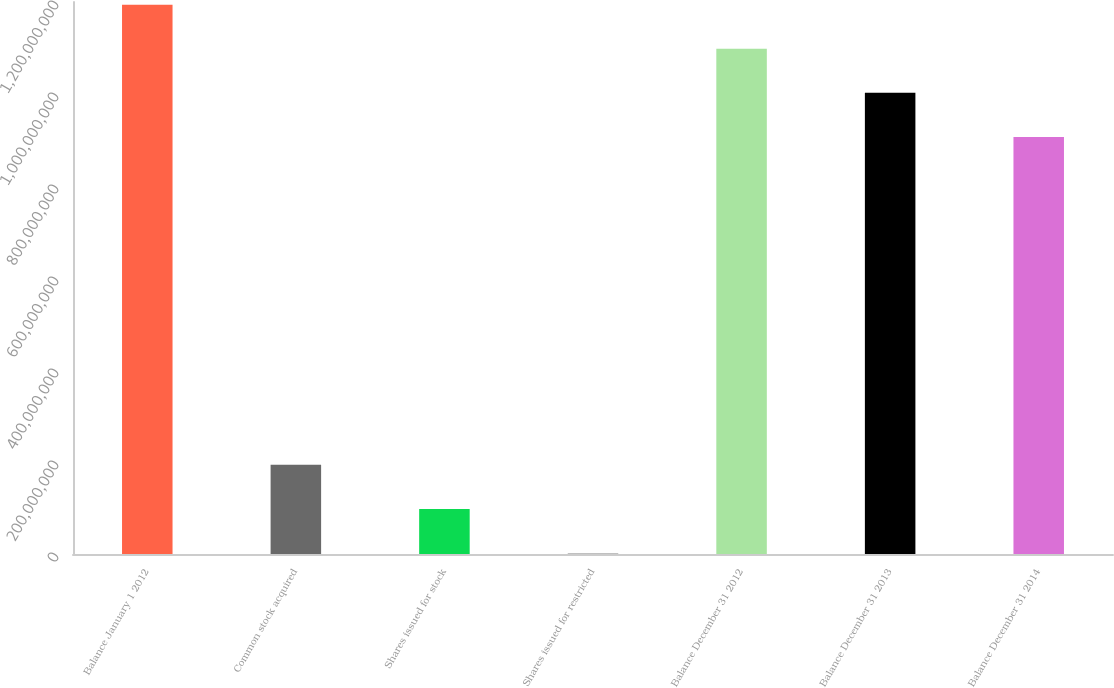Convert chart. <chart><loc_0><loc_0><loc_500><loc_500><bar_chart><fcel>Balance January 1 2012<fcel>Common stock acquired<fcel>Shares issued for stock<fcel>Shares issued for restricted<fcel>Balance December 31 2012<fcel>Balance December 31 2013<fcel>Balance December 31 2014<nl><fcel>1.19406e+09<fcel>1.93772e+08<fcel>9.79889e+07<fcel>2.2059e+06<fcel>1.09828e+09<fcel>1.0025e+09<fcel>9.06712e+08<nl></chart> 